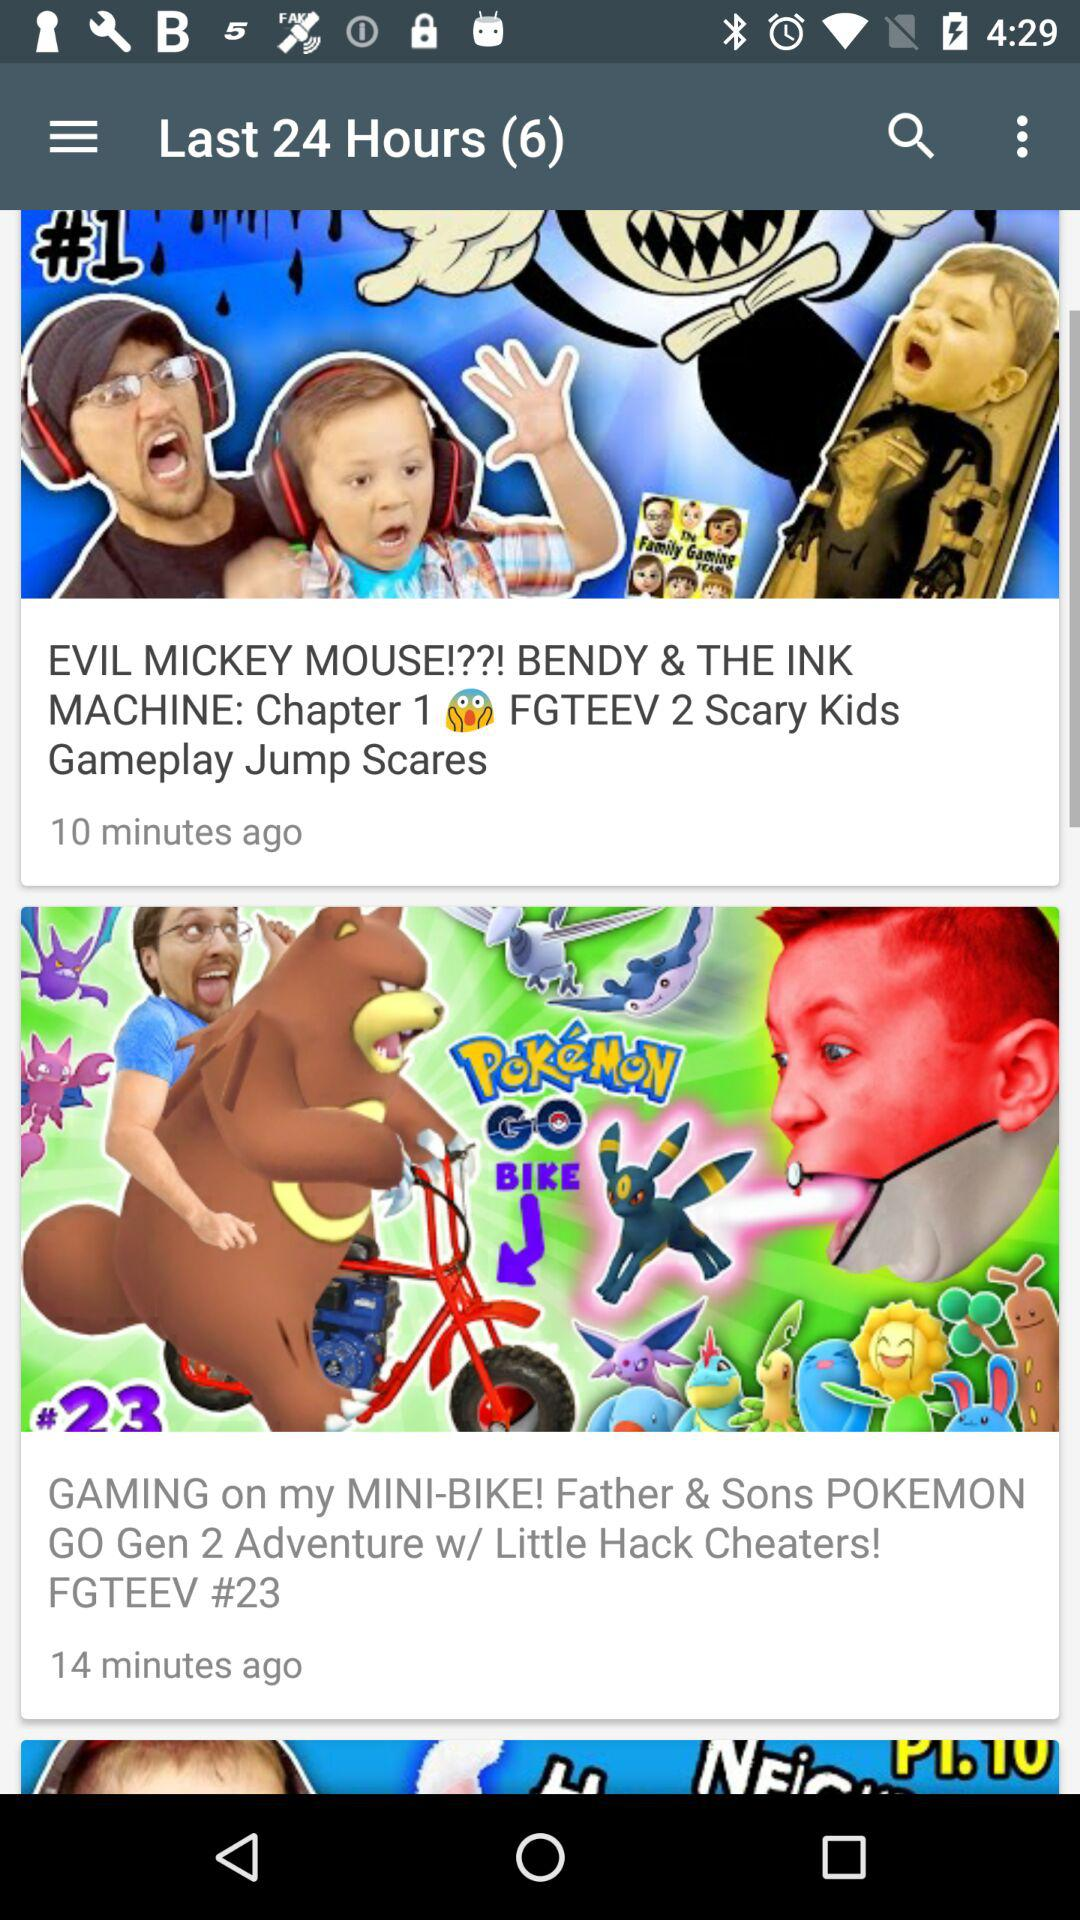When was "GAMING on my MINI-BIKE! Father & Sons POKEMON GO Gen 2 Adventure w/ Little Hack Cheaters! FGTEEV #23" uploaded? "GAMING on my MINI-BIKE! Father & Sons POKEMON GO Gen 2 Adventure w/ Little Hack Cheaters! FGTEEV #23" was uploaded 14 minutes ago. 